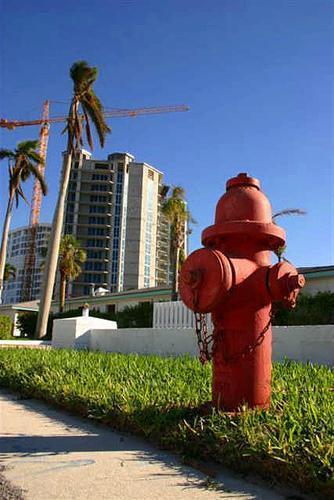How many hydrant are there?
Give a very brief answer. 1. How many fire hydrants are in the photo?
Give a very brief answer. 1. 